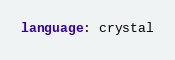Convert code to text. <code><loc_0><loc_0><loc_500><loc_500><_YAML_>language: crystal
</code> 